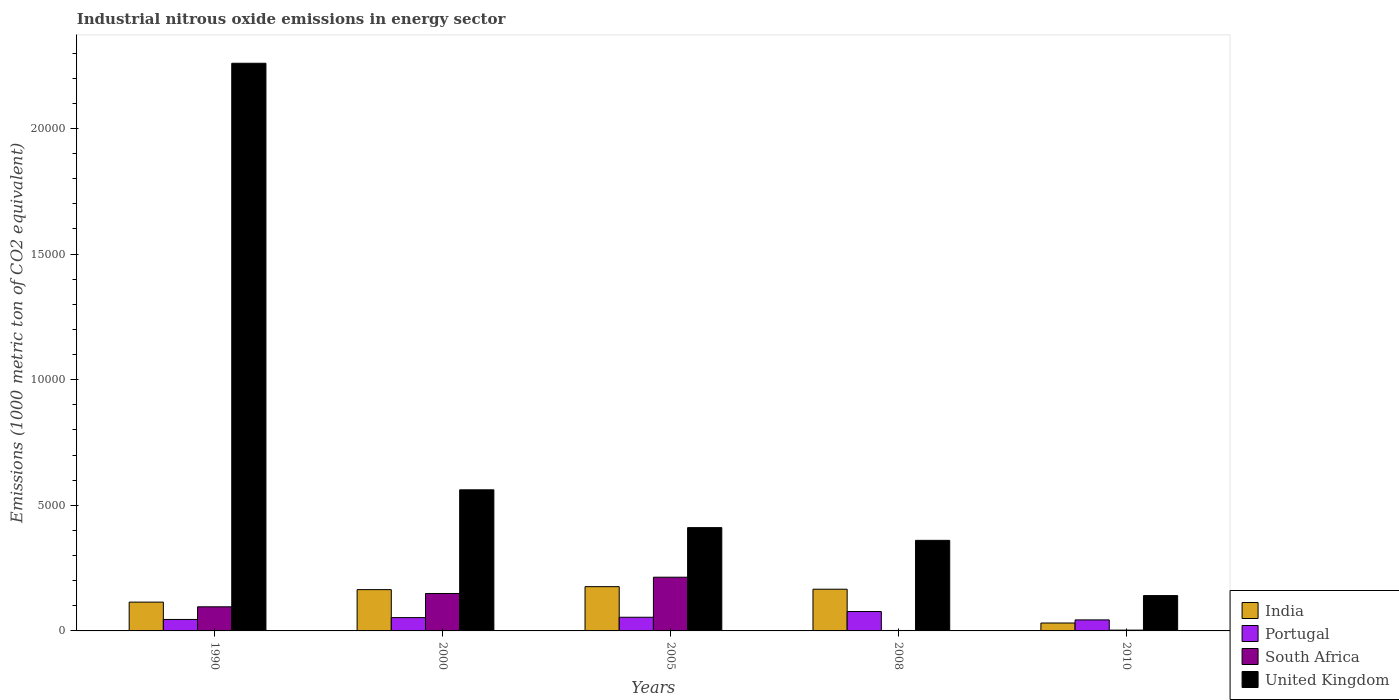How many different coloured bars are there?
Make the answer very short. 4. Are the number of bars per tick equal to the number of legend labels?
Give a very brief answer. Yes. How many bars are there on the 3rd tick from the right?
Offer a very short reply. 4. What is the amount of industrial nitrous oxide emitted in Portugal in 2010?
Your answer should be compact. 438.4. Across all years, what is the maximum amount of industrial nitrous oxide emitted in Portugal?
Offer a very short reply. 772.3. In which year was the amount of industrial nitrous oxide emitted in South Africa minimum?
Keep it short and to the point. 2008. What is the total amount of industrial nitrous oxide emitted in India in the graph?
Ensure brevity in your answer.  6526.6. What is the difference between the amount of industrial nitrous oxide emitted in Portugal in 2005 and that in 2008?
Provide a succinct answer. -228.4. What is the difference between the amount of industrial nitrous oxide emitted in United Kingdom in 2008 and the amount of industrial nitrous oxide emitted in Portugal in 2000?
Your answer should be compact. 3075.1. What is the average amount of industrial nitrous oxide emitted in Portugal per year?
Keep it short and to the point. 548.06. In the year 2005, what is the difference between the amount of industrial nitrous oxide emitted in India and amount of industrial nitrous oxide emitted in United Kingdom?
Keep it short and to the point. -2349.3. In how many years, is the amount of industrial nitrous oxide emitted in Portugal greater than 11000 1000 metric ton?
Your answer should be compact. 0. What is the ratio of the amount of industrial nitrous oxide emitted in Portugal in 2005 to that in 2010?
Your answer should be compact. 1.24. Is the difference between the amount of industrial nitrous oxide emitted in India in 1990 and 2010 greater than the difference between the amount of industrial nitrous oxide emitted in United Kingdom in 1990 and 2010?
Ensure brevity in your answer.  No. What is the difference between the highest and the second highest amount of industrial nitrous oxide emitted in South Africa?
Give a very brief answer. 647.5. What is the difference between the highest and the lowest amount of industrial nitrous oxide emitted in United Kingdom?
Your answer should be compact. 2.12e+04. Is the sum of the amount of industrial nitrous oxide emitted in Portugal in 2000 and 2005 greater than the maximum amount of industrial nitrous oxide emitted in India across all years?
Make the answer very short. No. Is it the case that in every year, the sum of the amount of industrial nitrous oxide emitted in India and amount of industrial nitrous oxide emitted in United Kingdom is greater than the sum of amount of industrial nitrous oxide emitted in Portugal and amount of industrial nitrous oxide emitted in South Africa?
Your answer should be compact. No. Is it the case that in every year, the sum of the amount of industrial nitrous oxide emitted in India and amount of industrial nitrous oxide emitted in United Kingdom is greater than the amount of industrial nitrous oxide emitted in Portugal?
Provide a short and direct response. Yes. How many bars are there?
Give a very brief answer. 20. How many years are there in the graph?
Offer a terse response. 5. Does the graph contain grids?
Offer a very short reply. No. Where does the legend appear in the graph?
Give a very brief answer. Bottom right. What is the title of the graph?
Your response must be concise. Industrial nitrous oxide emissions in energy sector. Does "Vietnam" appear as one of the legend labels in the graph?
Offer a very short reply. No. What is the label or title of the Y-axis?
Provide a succinct answer. Emissions (1000 metric ton of CO2 equivalent). What is the Emissions (1000 metric ton of CO2 equivalent) of India in 1990?
Give a very brief answer. 1146.7. What is the Emissions (1000 metric ton of CO2 equivalent) of Portugal in 1990?
Make the answer very short. 456.2. What is the Emissions (1000 metric ton of CO2 equivalent) of South Africa in 1990?
Provide a short and direct response. 959.8. What is the Emissions (1000 metric ton of CO2 equivalent) of United Kingdom in 1990?
Your response must be concise. 2.26e+04. What is the Emissions (1000 metric ton of CO2 equivalent) of India in 2000?
Offer a very short reply. 1643.3. What is the Emissions (1000 metric ton of CO2 equivalent) in Portugal in 2000?
Your answer should be compact. 529.5. What is the Emissions (1000 metric ton of CO2 equivalent) of South Africa in 2000?
Your answer should be very brief. 1489.9. What is the Emissions (1000 metric ton of CO2 equivalent) in United Kingdom in 2000?
Make the answer very short. 5616. What is the Emissions (1000 metric ton of CO2 equivalent) of India in 2005?
Your answer should be compact. 1761.9. What is the Emissions (1000 metric ton of CO2 equivalent) in Portugal in 2005?
Give a very brief answer. 543.9. What is the Emissions (1000 metric ton of CO2 equivalent) of South Africa in 2005?
Keep it short and to the point. 2137.4. What is the Emissions (1000 metric ton of CO2 equivalent) of United Kingdom in 2005?
Offer a terse response. 4111.2. What is the Emissions (1000 metric ton of CO2 equivalent) in India in 2008?
Ensure brevity in your answer.  1659.8. What is the Emissions (1000 metric ton of CO2 equivalent) in Portugal in 2008?
Keep it short and to the point. 772.3. What is the Emissions (1000 metric ton of CO2 equivalent) of United Kingdom in 2008?
Offer a very short reply. 3604.6. What is the Emissions (1000 metric ton of CO2 equivalent) of India in 2010?
Your answer should be compact. 314.9. What is the Emissions (1000 metric ton of CO2 equivalent) in Portugal in 2010?
Make the answer very short. 438.4. What is the Emissions (1000 metric ton of CO2 equivalent) of South Africa in 2010?
Provide a short and direct response. 31.7. What is the Emissions (1000 metric ton of CO2 equivalent) of United Kingdom in 2010?
Provide a short and direct response. 1406.6. Across all years, what is the maximum Emissions (1000 metric ton of CO2 equivalent) in India?
Your response must be concise. 1761.9. Across all years, what is the maximum Emissions (1000 metric ton of CO2 equivalent) in Portugal?
Your answer should be compact. 772.3. Across all years, what is the maximum Emissions (1000 metric ton of CO2 equivalent) in South Africa?
Offer a very short reply. 2137.4. Across all years, what is the maximum Emissions (1000 metric ton of CO2 equivalent) in United Kingdom?
Your answer should be very brief. 2.26e+04. Across all years, what is the minimum Emissions (1000 metric ton of CO2 equivalent) of India?
Your answer should be very brief. 314.9. Across all years, what is the minimum Emissions (1000 metric ton of CO2 equivalent) in Portugal?
Your answer should be compact. 438.4. Across all years, what is the minimum Emissions (1000 metric ton of CO2 equivalent) of United Kingdom?
Your response must be concise. 1406.6. What is the total Emissions (1000 metric ton of CO2 equivalent) in India in the graph?
Your answer should be compact. 6526.6. What is the total Emissions (1000 metric ton of CO2 equivalent) of Portugal in the graph?
Keep it short and to the point. 2740.3. What is the total Emissions (1000 metric ton of CO2 equivalent) of South Africa in the graph?
Give a very brief answer. 4636.7. What is the total Emissions (1000 metric ton of CO2 equivalent) of United Kingdom in the graph?
Your response must be concise. 3.73e+04. What is the difference between the Emissions (1000 metric ton of CO2 equivalent) of India in 1990 and that in 2000?
Your answer should be very brief. -496.6. What is the difference between the Emissions (1000 metric ton of CO2 equivalent) in Portugal in 1990 and that in 2000?
Provide a short and direct response. -73.3. What is the difference between the Emissions (1000 metric ton of CO2 equivalent) in South Africa in 1990 and that in 2000?
Provide a short and direct response. -530.1. What is the difference between the Emissions (1000 metric ton of CO2 equivalent) in United Kingdom in 1990 and that in 2000?
Your answer should be compact. 1.70e+04. What is the difference between the Emissions (1000 metric ton of CO2 equivalent) in India in 1990 and that in 2005?
Your response must be concise. -615.2. What is the difference between the Emissions (1000 metric ton of CO2 equivalent) of Portugal in 1990 and that in 2005?
Your response must be concise. -87.7. What is the difference between the Emissions (1000 metric ton of CO2 equivalent) of South Africa in 1990 and that in 2005?
Give a very brief answer. -1177.6. What is the difference between the Emissions (1000 metric ton of CO2 equivalent) of United Kingdom in 1990 and that in 2005?
Your answer should be compact. 1.85e+04. What is the difference between the Emissions (1000 metric ton of CO2 equivalent) in India in 1990 and that in 2008?
Offer a terse response. -513.1. What is the difference between the Emissions (1000 metric ton of CO2 equivalent) in Portugal in 1990 and that in 2008?
Ensure brevity in your answer.  -316.1. What is the difference between the Emissions (1000 metric ton of CO2 equivalent) in South Africa in 1990 and that in 2008?
Offer a terse response. 941.9. What is the difference between the Emissions (1000 metric ton of CO2 equivalent) of United Kingdom in 1990 and that in 2008?
Make the answer very short. 1.90e+04. What is the difference between the Emissions (1000 metric ton of CO2 equivalent) of India in 1990 and that in 2010?
Keep it short and to the point. 831.8. What is the difference between the Emissions (1000 metric ton of CO2 equivalent) of South Africa in 1990 and that in 2010?
Your response must be concise. 928.1. What is the difference between the Emissions (1000 metric ton of CO2 equivalent) of United Kingdom in 1990 and that in 2010?
Your response must be concise. 2.12e+04. What is the difference between the Emissions (1000 metric ton of CO2 equivalent) in India in 2000 and that in 2005?
Provide a succinct answer. -118.6. What is the difference between the Emissions (1000 metric ton of CO2 equivalent) in Portugal in 2000 and that in 2005?
Your answer should be compact. -14.4. What is the difference between the Emissions (1000 metric ton of CO2 equivalent) of South Africa in 2000 and that in 2005?
Keep it short and to the point. -647.5. What is the difference between the Emissions (1000 metric ton of CO2 equivalent) of United Kingdom in 2000 and that in 2005?
Give a very brief answer. 1504.8. What is the difference between the Emissions (1000 metric ton of CO2 equivalent) of India in 2000 and that in 2008?
Your answer should be very brief. -16.5. What is the difference between the Emissions (1000 metric ton of CO2 equivalent) of Portugal in 2000 and that in 2008?
Ensure brevity in your answer.  -242.8. What is the difference between the Emissions (1000 metric ton of CO2 equivalent) of South Africa in 2000 and that in 2008?
Your answer should be compact. 1472. What is the difference between the Emissions (1000 metric ton of CO2 equivalent) of United Kingdom in 2000 and that in 2008?
Your answer should be compact. 2011.4. What is the difference between the Emissions (1000 metric ton of CO2 equivalent) of India in 2000 and that in 2010?
Ensure brevity in your answer.  1328.4. What is the difference between the Emissions (1000 metric ton of CO2 equivalent) in Portugal in 2000 and that in 2010?
Make the answer very short. 91.1. What is the difference between the Emissions (1000 metric ton of CO2 equivalent) of South Africa in 2000 and that in 2010?
Ensure brevity in your answer.  1458.2. What is the difference between the Emissions (1000 metric ton of CO2 equivalent) in United Kingdom in 2000 and that in 2010?
Your answer should be compact. 4209.4. What is the difference between the Emissions (1000 metric ton of CO2 equivalent) in India in 2005 and that in 2008?
Your answer should be very brief. 102.1. What is the difference between the Emissions (1000 metric ton of CO2 equivalent) in Portugal in 2005 and that in 2008?
Ensure brevity in your answer.  -228.4. What is the difference between the Emissions (1000 metric ton of CO2 equivalent) of South Africa in 2005 and that in 2008?
Provide a succinct answer. 2119.5. What is the difference between the Emissions (1000 metric ton of CO2 equivalent) of United Kingdom in 2005 and that in 2008?
Ensure brevity in your answer.  506.6. What is the difference between the Emissions (1000 metric ton of CO2 equivalent) in India in 2005 and that in 2010?
Provide a succinct answer. 1447. What is the difference between the Emissions (1000 metric ton of CO2 equivalent) in Portugal in 2005 and that in 2010?
Provide a short and direct response. 105.5. What is the difference between the Emissions (1000 metric ton of CO2 equivalent) in South Africa in 2005 and that in 2010?
Your answer should be very brief. 2105.7. What is the difference between the Emissions (1000 metric ton of CO2 equivalent) of United Kingdom in 2005 and that in 2010?
Offer a terse response. 2704.6. What is the difference between the Emissions (1000 metric ton of CO2 equivalent) of India in 2008 and that in 2010?
Make the answer very short. 1344.9. What is the difference between the Emissions (1000 metric ton of CO2 equivalent) in Portugal in 2008 and that in 2010?
Provide a succinct answer. 333.9. What is the difference between the Emissions (1000 metric ton of CO2 equivalent) of South Africa in 2008 and that in 2010?
Your answer should be very brief. -13.8. What is the difference between the Emissions (1000 metric ton of CO2 equivalent) of United Kingdom in 2008 and that in 2010?
Offer a terse response. 2198. What is the difference between the Emissions (1000 metric ton of CO2 equivalent) in India in 1990 and the Emissions (1000 metric ton of CO2 equivalent) in Portugal in 2000?
Provide a succinct answer. 617.2. What is the difference between the Emissions (1000 metric ton of CO2 equivalent) in India in 1990 and the Emissions (1000 metric ton of CO2 equivalent) in South Africa in 2000?
Offer a very short reply. -343.2. What is the difference between the Emissions (1000 metric ton of CO2 equivalent) of India in 1990 and the Emissions (1000 metric ton of CO2 equivalent) of United Kingdom in 2000?
Ensure brevity in your answer.  -4469.3. What is the difference between the Emissions (1000 metric ton of CO2 equivalent) of Portugal in 1990 and the Emissions (1000 metric ton of CO2 equivalent) of South Africa in 2000?
Give a very brief answer. -1033.7. What is the difference between the Emissions (1000 metric ton of CO2 equivalent) in Portugal in 1990 and the Emissions (1000 metric ton of CO2 equivalent) in United Kingdom in 2000?
Keep it short and to the point. -5159.8. What is the difference between the Emissions (1000 metric ton of CO2 equivalent) in South Africa in 1990 and the Emissions (1000 metric ton of CO2 equivalent) in United Kingdom in 2000?
Give a very brief answer. -4656.2. What is the difference between the Emissions (1000 metric ton of CO2 equivalent) of India in 1990 and the Emissions (1000 metric ton of CO2 equivalent) of Portugal in 2005?
Offer a terse response. 602.8. What is the difference between the Emissions (1000 metric ton of CO2 equivalent) of India in 1990 and the Emissions (1000 metric ton of CO2 equivalent) of South Africa in 2005?
Offer a very short reply. -990.7. What is the difference between the Emissions (1000 metric ton of CO2 equivalent) of India in 1990 and the Emissions (1000 metric ton of CO2 equivalent) of United Kingdom in 2005?
Make the answer very short. -2964.5. What is the difference between the Emissions (1000 metric ton of CO2 equivalent) of Portugal in 1990 and the Emissions (1000 metric ton of CO2 equivalent) of South Africa in 2005?
Offer a very short reply. -1681.2. What is the difference between the Emissions (1000 metric ton of CO2 equivalent) in Portugal in 1990 and the Emissions (1000 metric ton of CO2 equivalent) in United Kingdom in 2005?
Your answer should be very brief. -3655. What is the difference between the Emissions (1000 metric ton of CO2 equivalent) in South Africa in 1990 and the Emissions (1000 metric ton of CO2 equivalent) in United Kingdom in 2005?
Your response must be concise. -3151.4. What is the difference between the Emissions (1000 metric ton of CO2 equivalent) in India in 1990 and the Emissions (1000 metric ton of CO2 equivalent) in Portugal in 2008?
Provide a short and direct response. 374.4. What is the difference between the Emissions (1000 metric ton of CO2 equivalent) of India in 1990 and the Emissions (1000 metric ton of CO2 equivalent) of South Africa in 2008?
Give a very brief answer. 1128.8. What is the difference between the Emissions (1000 metric ton of CO2 equivalent) in India in 1990 and the Emissions (1000 metric ton of CO2 equivalent) in United Kingdom in 2008?
Offer a terse response. -2457.9. What is the difference between the Emissions (1000 metric ton of CO2 equivalent) in Portugal in 1990 and the Emissions (1000 metric ton of CO2 equivalent) in South Africa in 2008?
Make the answer very short. 438.3. What is the difference between the Emissions (1000 metric ton of CO2 equivalent) in Portugal in 1990 and the Emissions (1000 metric ton of CO2 equivalent) in United Kingdom in 2008?
Provide a succinct answer. -3148.4. What is the difference between the Emissions (1000 metric ton of CO2 equivalent) of South Africa in 1990 and the Emissions (1000 metric ton of CO2 equivalent) of United Kingdom in 2008?
Provide a short and direct response. -2644.8. What is the difference between the Emissions (1000 metric ton of CO2 equivalent) in India in 1990 and the Emissions (1000 metric ton of CO2 equivalent) in Portugal in 2010?
Give a very brief answer. 708.3. What is the difference between the Emissions (1000 metric ton of CO2 equivalent) in India in 1990 and the Emissions (1000 metric ton of CO2 equivalent) in South Africa in 2010?
Your answer should be very brief. 1115. What is the difference between the Emissions (1000 metric ton of CO2 equivalent) of India in 1990 and the Emissions (1000 metric ton of CO2 equivalent) of United Kingdom in 2010?
Offer a terse response. -259.9. What is the difference between the Emissions (1000 metric ton of CO2 equivalent) of Portugal in 1990 and the Emissions (1000 metric ton of CO2 equivalent) of South Africa in 2010?
Offer a terse response. 424.5. What is the difference between the Emissions (1000 metric ton of CO2 equivalent) in Portugal in 1990 and the Emissions (1000 metric ton of CO2 equivalent) in United Kingdom in 2010?
Offer a very short reply. -950.4. What is the difference between the Emissions (1000 metric ton of CO2 equivalent) of South Africa in 1990 and the Emissions (1000 metric ton of CO2 equivalent) of United Kingdom in 2010?
Keep it short and to the point. -446.8. What is the difference between the Emissions (1000 metric ton of CO2 equivalent) of India in 2000 and the Emissions (1000 metric ton of CO2 equivalent) of Portugal in 2005?
Your answer should be compact. 1099.4. What is the difference between the Emissions (1000 metric ton of CO2 equivalent) of India in 2000 and the Emissions (1000 metric ton of CO2 equivalent) of South Africa in 2005?
Keep it short and to the point. -494.1. What is the difference between the Emissions (1000 metric ton of CO2 equivalent) in India in 2000 and the Emissions (1000 metric ton of CO2 equivalent) in United Kingdom in 2005?
Ensure brevity in your answer.  -2467.9. What is the difference between the Emissions (1000 metric ton of CO2 equivalent) of Portugal in 2000 and the Emissions (1000 metric ton of CO2 equivalent) of South Africa in 2005?
Provide a succinct answer. -1607.9. What is the difference between the Emissions (1000 metric ton of CO2 equivalent) in Portugal in 2000 and the Emissions (1000 metric ton of CO2 equivalent) in United Kingdom in 2005?
Your answer should be very brief. -3581.7. What is the difference between the Emissions (1000 metric ton of CO2 equivalent) of South Africa in 2000 and the Emissions (1000 metric ton of CO2 equivalent) of United Kingdom in 2005?
Give a very brief answer. -2621.3. What is the difference between the Emissions (1000 metric ton of CO2 equivalent) in India in 2000 and the Emissions (1000 metric ton of CO2 equivalent) in Portugal in 2008?
Give a very brief answer. 871. What is the difference between the Emissions (1000 metric ton of CO2 equivalent) in India in 2000 and the Emissions (1000 metric ton of CO2 equivalent) in South Africa in 2008?
Your answer should be compact. 1625.4. What is the difference between the Emissions (1000 metric ton of CO2 equivalent) in India in 2000 and the Emissions (1000 metric ton of CO2 equivalent) in United Kingdom in 2008?
Give a very brief answer. -1961.3. What is the difference between the Emissions (1000 metric ton of CO2 equivalent) in Portugal in 2000 and the Emissions (1000 metric ton of CO2 equivalent) in South Africa in 2008?
Provide a short and direct response. 511.6. What is the difference between the Emissions (1000 metric ton of CO2 equivalent) in Portugal in 2000 and the Emissions (1000 metric ton of CO2 equivalent) in United Kingdom in 2008?
Give a very brief answer. -3075.1. What is the difference between the Emissions (1000 metric ton of CO2 equivalent) of South Africa in 2000 and the Emissions (1000 metric ton of CO2 equivalent) of United Kingdom in 2008?
Provide a short and direct response. -2114.7. What is the difference between the Emissions (1000 metric ton of CO2 equivalent) of India in 2000 and the Emissions (1000 metric ton of CO2 equivalent) of Portugal in 2010?
Provide a short and direct response. 1204.9. What is the difference between the Emissions (1000 metric ton of CO2 equivalent) in India in 2000 and the Emissions (1000 metric ton of CO2 equivalent) in South Africa in 2010?
Your answer should be very brief. 1611.6. What is the difference between the Emissions (1000 metric ton of CO2 equivalent) in India in 2000 and the Emissions (1000 metric ton of CO2 equivalent) in United Kingdom in 2010?
Offer a very short reply. 236.7. What is the difference between the Emissions (1000 metric ton of CO2 equivalent) of Portugal in 2000 and the Emissions (1000 metric ton of CO2 equivalent) of South Africa in 2010?
Provide a succinct answer. 497.8. What is the difference between the Emissions (1000 metric ton of CO2 equivalent) in Portugal in 2000 and the Emissions (1000 metric ton of CO2 equivalent) in United Kingdom in 2010?
Offer a very short reply. -877.1. What is the difference between the Emissions (1000 metric ton of CO2 equivalent) in South Africa in 2000 and the Emissions (1000 metric ton of CO2 equivalent) in United Kingdom in 2010?
Your answer should be compact. 83.3. What is the difference between the Emissions (1000 metric ton of CO2 equivalent) of India in 2005 and the Emissions (1000 metric ton of CO2 equivalent) of Portugal in 2008?
Offer a terse response. 989.6. What is the difference between the Emissions (1000 metric ton of CO2 equivalent) of India in 2005 and the Emissions (1000 metric ton of CO2 equivalent) of South Africa in 2008?
Make the answer very short. 1744. What is the difference between the Emissions (1000 metric ton of CO2 equivalent) in India in 2005 and the Emissions (1000 metric ton of CO2 equivalent) in United Kingdom in 2008?
Provide a succinct answer. -1842.7. What is the difference between the Emissions (1000 metric ton of CO2 equivalent) in Portugal in 2005 and the Emissions (1000 metric ton of CO2 equivalent) in South Africa in 2008?
Make the answer very short. 526. What is the difference between the Emissions (1000 metric ton of CO2 equivalent) of Portugal in 2005 and the Emissions (1000 metric ton of CO2 equivalent) of United Kingdom in 2008?
Give a very brief answer. -3060.7. What is the difference between the Emissions (1000 metric ton of CO2 equivalent) in South Africa in 2005 and the Emissions (1000 metric ton of CO2 equivalent) in United Kingdom in 2008?
Ensure brevity in your answer.  -1467.2. What is the difference between the Emissions (1000 metric ton of CO2 equivalent) of India in 2005 and the Emissions (1000 metric ton of CO2 equivalent) of Portugal in 2010?
Your answer should be compact. 1323.5. What is the difference between the Emissions (1000 metric ton of CO2 equivalent) in India in 2005 and the Emissions (1000 metric ton of CO2 equivalent) in South Africa in 2010?
Make the answer very short. 1730.2. What is the difference between the Emissions (1000 metric ton of CO2 equivalent) of India in 2005 and the Emissions (1000 metric ton of CO2 equivalent) of United Kingdom in 2010?
Your answer should be very brief. 355.3. What is the difference between the Emissions (1000 metric ton of CO2 equivalent) of Portugal in 2005 and the Emissions (1000 metric ton of CO2 equivalent) of South Africa in 2010?
Keep it short and to the point. 512.2. What is the difference between the Emissions (1000 metric ton of CO2 equivalent) in Portugal in 2005 and the Emissions (1000 metric ton of CO2 equivalent) in United Kingdom in 2010?
Your answer should be very brief. -862.7. What is the difference between the Emissions (1000 metric ton of CO2 equivalent) in South Africa in 2005 and the Emissions (1000 metric ton of CO2 equivalent) in United Kingdom in 2010?
Make the answer very short. 730.8. What is the difference between the Emissions (1000 metric ton of CO2 equivalent) of India in 2008 and the Emissions (1000 metric ton of CO2 equivalent) of Portugal in 2010?
Your response must be concise. 1221.4. What is the difference between the Emissions (1000 metric ton of CO2 equivalent) in India in 2008 and the Emissions (1000 metric ton of CO2 equivalent) in South Africa in 2010?
Your answer should be compact. 1628.1. What is the difference between the Emissions (1000 metric ton of CO2 equivalent) of India in 2008 and the Emissions (1000 metric ton of CO2 equivalent) of United Kingdom in 2010?
Your answer should be very brief. 253.2. What is the difference between the Emissions (1000 metric ton of CO2 equivalent) in Portugal in 2008 and the Emissions (1000 metric ton of CO2 equivalent) in South Africa in 2010?
Your answer should be compact. 740.6. What is the difference between the Emissions (1000 metric ton of CO2 equivalent) in Portugal in 2008 and the Emissions (1000 metric ton of CO2 equivalent) in United Kingdom in 2010?
Provide a short and direct response. -634.3. What is the difference between the Emissions (1000 metric ton of CO2 equivalent) of South Africa in 2008 and the Emissions (1000 metric ton of CO2 equivalent) of United Kingdom in 2010?
Your answer should be very brief. -1388.7. What is the average Emissions (1000 metric ton of CO2 equivalent) in India per year?
Keep it short and to the point. 1305.32. What is the average Emissions (1000 metric ton of CO2 equivalent) in Portugal per year?
Provide a succinct answer. 548.06. What is the average Emissions (1000 metric ton of CO2 equivalent) of South Africa per year?
Your answer should be very brief. 927.34. What is the average Emissions (1000 metric ton of CO2 equivalent) of United Kingdom per year?
Provide a succinct answer. 7466.28. In the year 1990, what is the difference between the Emissions (1000 metric ton of CO2 equivalent) in India and Emissions (1000 metric ton of CO2 equivalent) in Portugal?
Your answer should be compact. 690.5. In the year 1990, what is the difference between the Emissions (1000 metric ton of CO2 equivalent) in India and Emissions (1000 metric ton of CO2 equivalent) in South Africa?
Make the answer very short. 186.9. In the year 1990, what is the difference between the Emissions (1000 metric ton of CO2 equivalent) in India and Emissions (1000 metric ton of CO2 equivalent) in United Kingdom?
Provide a succinct answer. -2.14e+04. In the year 1990, what is the difference between the Emissions (1000 metric ton of CO2 equivalent) in Portugal and Emissions (1000 metric ton of CO2 equivalent) in South Africa?
Your answer should be very brief. -503.6. In the year 1990, what is the difference between the Emissions (1000 metric ton of CO2 equivalent) of Portugal and Emissions (1000 metric ton of CO2 equivalent) of United Kingdom?
Your answer should be very brief. -2.21e+04. In the year 1990, what is the difference between the Emissions (1000 metric ton of CO2 equivalent) of South Africa and Emissions (1000 metric ton of CO2 equivalent) of United Kingdom?
Offer a terse response. -2.16e+04. In the year 2000, what is the difference between the Emissions (1000 metric ton of CO2 equivalent) in India and Emissions (1000 metric ton of CO2 equivalent) in Portugal?
Your answer should be very brief. 1113.8. In the year 2000, what is the difference between the Emissions (1000 metric ton of CO2 equivalent) in India and Emissions (1000 metric ton of CO2 equivalent) in South Africa?
Your response must be concise. 153.4. In the year 2000, what is the difference between the Emissions (1000 metric ton of CO2 equivalent) in India and Emissions (1000 metric ton of CO2 equivalent) in United Kingdom?
Your answer should be compact. -3972.7. In the year 2000, what is the difference between the Emissions (1000 metric ton of CO2 equivalent) in Portugal and Emissions (1000 metric ton of CO2 equivalent) in South Africa?
Offer a very short reply. -960.4. In the year 2000, what is the difference between the Emissions (1000 metric ton of CO2 equivalent) of Portugal and Emissions (1000 metric ton of CO2 equivalent) of United Kingdom?
Make the answer very short. -5086.5. In the year 2000, what is the difference between the Emissions (1000 metric ton of CO2 equivalent) of South Africa and Emissions (1000 metric ton of CO2 equivalent) of United Kingdom?
Offer a very short reply. -4126.1. In the year 2005, what is the difference between the Emissions (1000 metric ton of CO2 equivalent) of India and Emissions (1000 metric ton of CO2 equivalent) of Portugal?
Make the answer very short. 1218. In the year 2005, what is the difference between the Emissions (1000 metric ton of CO2 equivalent) of India and Emissions (1000 metric ton of CO2 equivalent) of South Africa?
Your response must be concise. -375.5. In the year 2005, what is the difference between the Emissions (1000 metric ton of CO2 equivalent) in India and Emissions (1000 metric ton of CO2 equivalent) in United Kingdom?
Provide a succinct answer. -2349.3. In the year 2005, what is the difference between the Emissions (1000 metric ton of CO2 equivalent) in Portugal and Emissions (1000 metric ton of CO2 equivalent) in South Africa?
Offer a very short reply. -1593.5. In the year 2005, what is the difference between the Emissions (1000 metric ton of CO2 equivalent) of Portugal and Emissions (1000 metric ton of CO2 equivalent) of United Kingdom?
Your response must be concise. -3567.3. In the year 2005, what is the difference between the Emissions (1000 metric ton of CO2 equivalent) of South Africa and Emissions (1000 metric ton of CO2 equivalent) of United Kingdom?
Ensure brevity in your answer.  -1973.8. In the year 2008, what is the difference between the Emissions (1000 metric ton of CO2 equivalent) in India and Emissions (1000 metric ton of CO2 equivalent) in Portugal?
Offer a terse response. 887.5. In the year 2008, what is the difference between the Emissions (1000 metric ton of CO2 equivalent) of India and Emissions (1000 metric ton of CO2 equivalent) of South Africa?
Your response must be concise. 1641.9. In the year 2008, what is the difference between the Emissions (1000 metric ton of CO2 equivalent) of India and Emissions (1000 metric ton of CO2 equivalent) of United Kingdom?
Offer a terse response. -1944.8. In the year 2008, what is the difference between the Emissions (1000 metric ton of CO2 equivalent) of Portugal and Emissions (1000 metric ton of CO2 equivalent) of South Africa?
Your answer should be compact. 754.4. In the year 2008, what is the difference between the Emissions (1000 metric ton of CO2 equivalent) in Portugal and Emissions (1000 metric ton of CO2 equivalent) in United Kingdom?
Provide a short and direct response. -2832.3. In the year 2008, what is the difference between the Emissions (1000 metric ton of CO2 equivalent) of South Africa and Emissions (1000 metric ton of CO2 equivalent) of United Kingdom?
Make the answer very short. -3586.7. In the year 2010, what is the difference between the Emissions (1000 metric ton of CO2 equivalent) in India and Emissions (1000 metric ton of CO2 equivalent) in Portugal?
Offer a very short reply. -123.5. In the year 2010, what is the difference between the Emissions (1000 metric ton of CO2 equivalent) of India and Emissions (1000 metric ton of CO2 equivalent) of South Africa?
Make the answer very short. 283.2. In the year 2010, what is the difference between the Emissions (1000 metric ton of CO2 equivalent) in India and Emissions (1000 metric ton of CO2 equivalent) in United Kingdom?
Offer a terse response. -1091.7. In the year 2010, what is the difference between the Emissions (1000 metric ton of CO2 equivalent) of Portugal and Emissions (1000 metric ton of CO2 equivalent) of South Africa?
Your answer should be compact. 406.7. In the year 2010, what is the difference between the Emissions (1000 metric ton of CO2 equivalent) of Portugal and Emissions (1000 metric ton of CO2 equivalent) of United Kingdom?
Keep it short and to the point. -968.2. In the year 2010, what is the difference between the Emissions (1000 metric ton of CO2 equivalent) in South Africa and Emissions (1000 metric ton of CO2 equivalent) in United Kingdom?
Make the answer very short. -1374.9. What is the ratio of the Emissions (1000 metric ton of CO2 equivalent) of India in 1990 to that in 2000?
Provide a succinct answer. 0.7. What is the ratio of the Emissions (1000 metric ton of CO2 equivalent) in Portugal in 1990 to that in 2000?
Give a very brief answer. 0.86. What is the ratio of the Emissions (1000 metric ton of CO2 equivalent) of South Africa in 1990 to that in 2000?
Provide a short and direct response. 0.64. What is the ratio of the Emissions (1000 metric ton of CO2 equivalent) in United Kingdom in 1990 to that in 2000?
Make the answer very short. 4.02. What is the ratio of the Emissions (1000 metric ton of CO2 equivalent) of India in 1990 to that in 2005?
Make the answer very short. 0.65. What is the ratio of the Emissions (1000 metric ton of CO2 equivalent) of Portugal in 1990 to that in 2005?
Make the answer very short. 0.84. What is the ratio of the Emissions (1000 metric ton of CO2 equivalent) of South Africa in 1990 to that in 2005?
Your answer should be very brief. 0.45. What is the ratio of the Emissions (1000 metric ton of CO2 equivalent) in United Kingdom in 1990 to that in 2005?
Your answer should be very brief. 5.5. What is the ratio of the Emissions (1000 metric ton of CO2 equivalent) in India in 1990 to that in 2008?
Offer a terse response. 0.69. What is the ratio of the Emissions (1000 metric ton of CO2 equivalent) of Portugal in 1990 to that in 2008?
Offer a very short reply. 0.59. What is the ratio of the Emissions (1000 metric ton of CO2 equivalent) of South Africa in 1990 to that in 2008?
Make the answer very short. 53.62. What is the ratio of the Emissions (1000 metric ton of CO2 equivalent) of United Kingdom in 1990 to that in 2008?
Provide a short and direct response. 6.27. What is the ratio of the Emissions (1000 metric ton of CO2 equivalent) in India in 1990 to that in 2010?
Your answer should be very brief. 3.64. What is the ratio of the Emissions (1000 metric ton of CO2 equivalent) in Portugal in 1990 to that in 2010?
Make the answer very short. 1.04. What is the ratio of the Emissions (1000 metric ton of CO2 equivalent) in South Africa in 1990 to that in 2010?
Provide a short and direct response. 30.28. What is the ratio of the Emissions (1000 metric ton of CO2 equivalent) of United Kingdom in 1990 to that in 2010?
Offer a terse response. 16.06. What is the ratio of the Emissions (1000 metric ton of CO2 equivalent) of India in 2000 to that in 2005?
Make the answer very short. 0.93. What is the ratio of the Emissions (1000 metric ton of CO2 equivalent) in Portugal in 2000 to that in 2005?
Ensure brevity in your answer.  0.97. What is the ratio of the Emissions (1000 metric ton of CO2 equivalent) of South Africa in 2000 to that in 2005?
Your answer should be compact. 0.7. What is the ratio of the Emissions (1000 metric ton of CO2 equivalent) in United Kingdom in 2000 to that in 2005?
Make the answer very short. 1.37. What is the ratio of the Emissions (1000 metric ton of CO2 equivalent) of India in 2000 to that in 2008?
Offer a very short reply. 0.99. What is the ratio of the Emissions (1000 metric ton of CO2 equivalent) in Portugal in 2000 to that in 2008?
Give a very brief answer. 0.69. What is the ratio of the Emissions (1000 metric ton of CO2 equivalent) in South Africa in 2000 to that in 2008?
Provide a short and direct response. 83.23. What is the ratio of the Emissions (1000 metric ton of CO2 equivalent) in United Kingdom in 2000 to that in 2008?
Provide a short and direct response. 1.56. What is the ratio of the Emissions (1000 metric ton of CO2 equivalent) of India in 2000 to that in 2010?
Ensure brevity in your answer.  5.22. What is the ratio of the Emissions (1000 metric ton of CO2 equivalent) of Portugal in 2000 to that in 2010?
Your response must be concise. 1.21. What is the ratio of the Emissions (1000 metric ton of CO2 equivalent) in South Africa in 2000 to that in 2010?
Keep it short and to the point. 47. What is the ratio of the Emissions (1000 metric ton of CO2 equivalent) in United Kingdom in 2000 to that in 2010?
Offer a terse response. 3.99. What is the ratio of the Emissions (1000 metric ton of CO2 equivalent) in India in 2005 to that in 2008?
Provide a short and direct response. 1.06. What is the ratio of the Emissions (1000 metric ton of CO2 equivalent) of Portugal in 2005 to that in 2008?
Your answer should be compact. 0.7. What is the ratio of the Emissions (1000 metric ton of CO2 equivalent) in South Africa in 2005 to that in 2008?
Provide a succinct answer. 119.41. What is the ratio of the Emissions (1000 metric ton of CO2 equivalent) in United Kingdom in 2005 to that in 2008?
Provide a succinct answer. 1.14. What is the ratio of the Emissions (1000 metric ton of CO2 equivalent) in India in 2005 to that in 2010?
Keep it short and to the point. 5.6. What is the ratio of the Emissions (1000 metric ton of CO2 equivalent) in Portugal in 2005 to that in 2010?
Ensure brevity in your answer.  1.24. What is the ratio of the Emissions (1000 metric ton of CO2 equivalent) of South Africa in 2005 to that in 2010?
Keep it short and to the point. 67.43. What is the ratio of the Emissions (1000 metric ton of CO2 equivalent) in United Kingdom in 2005 to that in 2010?
Your response must be concise. 2.92. What is the ratio of the Emissions (1000 metric ton of CO2 equivalent) of India in 2008 to that in 2010?
Provide a succinct answer. 5.27. What is the ratio of the Emissions (1000 metric ton of CO2 equivalent) in Portugal in 2008 to that in 2010?
Provide a succinct answer. 1.76. What is the ratio of the Emissions (1000 metric ton of CO2 equivalent) of South Africa in 2008 to that in 2010?
Offer a terse response. 0.56. What is the ratio of the Emissions (1000 metric ton of CO2 equivalent) of United Kingdom in 2008 to that in 2010?
Provide a short and direct response. 2.56. What is the difference between the highest and the second highest Emissions (1000 metric ton of CO2 equivalent) in India?
Offer a terse response. 102.1. What is the difference between the highest and the second highest Emissions (1000 metric ton of CO2 equivalent) in Portugal?
Your response must be concise. 228.4. What is the difference between the highest and the second highest Emissions (1000 metric ton of CO2 equivalent) in South Africa?
Provide a succinct answer. 647.5. What is the difference between the highest and the second highest Emissions (1000 metric ton of CO2 equivalent) in United Kingdom?
Your answer should be very brief. 1.70e+04. What is the difference between the highest and the lowest Emissions (1000 metric ton of CO2 equivalent) in India?
Provide a succinct answer. 1447. What is the difference between the highest and the lowest Emissions (1000 metric ton of CO2 equivalent) of Portugal?
Offer a terse response. 333.9. What is the difference between the highest and the lowest Emissions (1000 metric ton of CO2 equivalent) in South Africa?
Keep it short and to the point. 2119.5. What is the difference between the highest and the lowest Emissions (1000 metric ton of CO2 equivalent) of United Kingdom?
Give a very brief answer. 2.12e+04. 